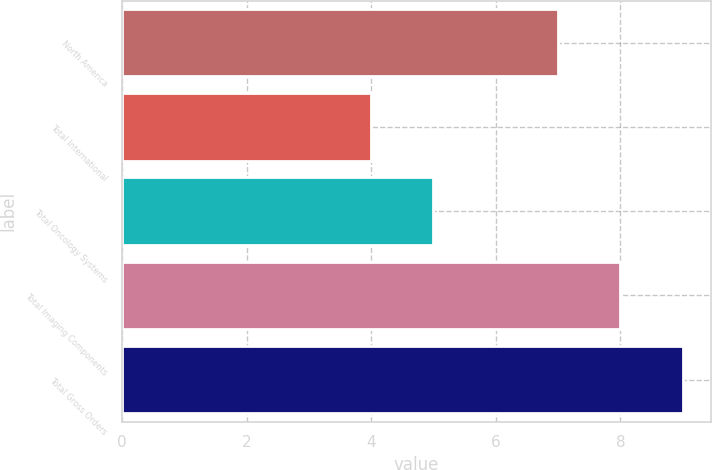<chart> <loc_0><loc_0><loc_500><loc_500><bar_chart><fcel>North America<fcel>Total International<fcel>Total Oncology Systems<fcel>Total Imaging Components<fcel>Total Gross Orders<nl><fcel>7<fcel>4<fcel>5<fcel>8<fcel>9<nl></chart> 